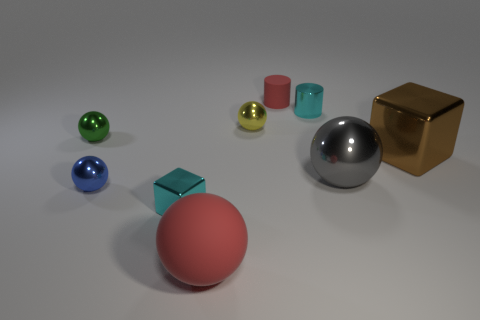Subtract all tiny metallic balls. How many balls are left? 2 Subtract all red spheres. How many spheres are left? 4 Subtract 1 balls. How many balls are left? 4 Subtract all blocks. How many objects are left? 7 Subtract 1 blue balls. How many objects are left? 8 Subtract all cyan cylinders. Subtract all cyan blocks. How many cylinders are left? 1 Subtract all small shiny things. Subtract all tiny red matte cylinders. How many objects are left? 3 Add 7 blue metal things. How many blue metal things are left? 8 Add 7 tiny balls. How many tiny balls exist? 10 